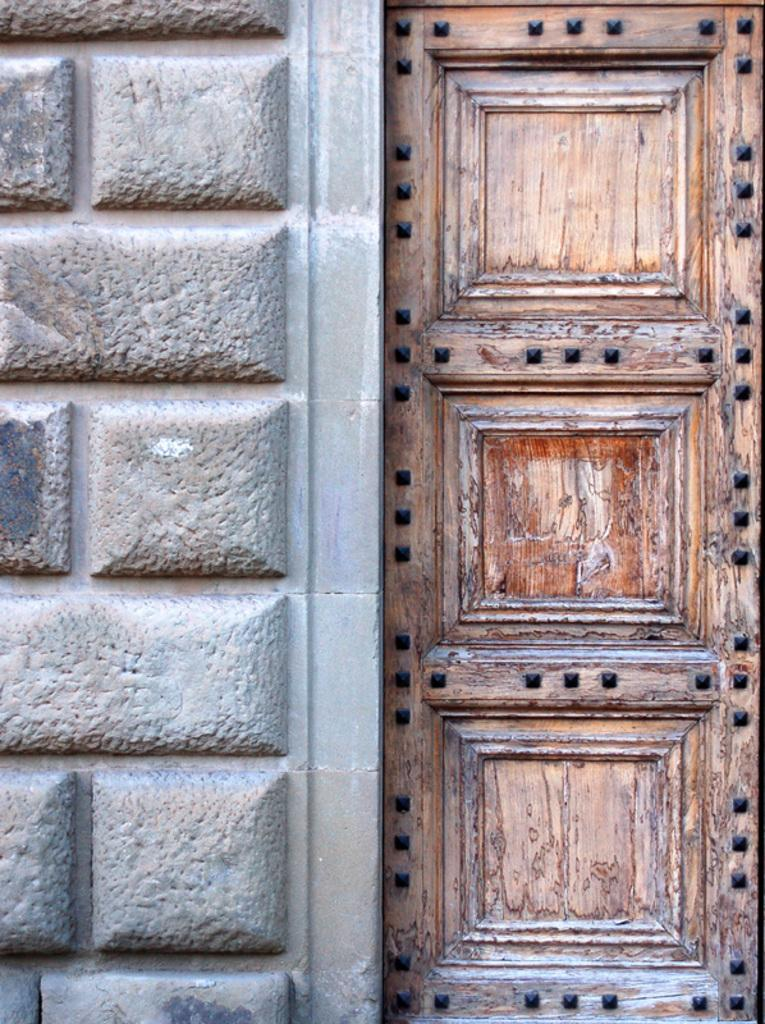What structure is located on the right side of the image? There is a door on the right side of the image. What can be seen on the left side of the image? There is a wall on the left side of the image. Where is the secretary sitting in the image? There is no secretary present in the image. What type of wire can be seen connecting the objects in the image? There is no wire connecting any objects in the image. 